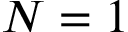<formula> <loc_0><loc_0><loc_500><loc_500>N = 1</formula> 